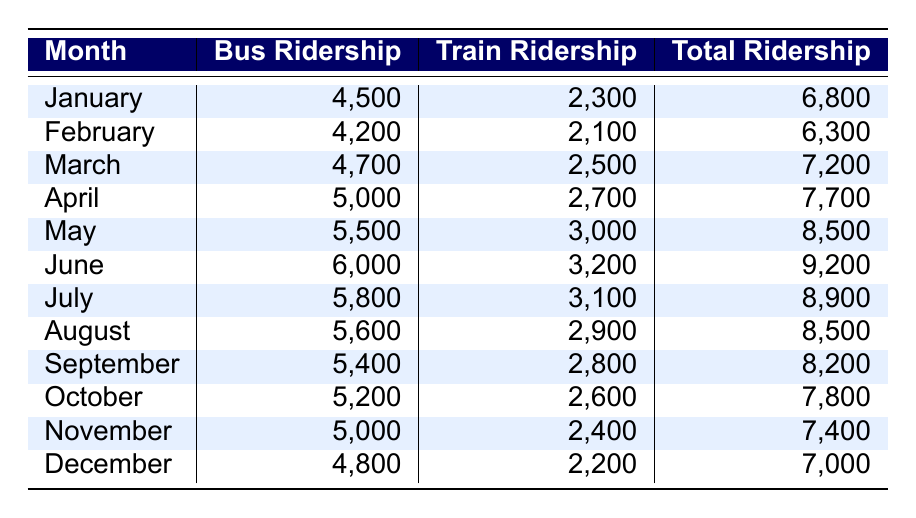What was the total ridership in June? The table shows that the total ridership for June is listed under the "Total Ridership" column. Referring to the row for June, the value is 9,200.
Answer: 9,200 Which month had the highest bus ridership? Looking at the "Bus Ridership" column, June has the highest value listed at 6,000, which is greater than all other monthly values.
Answer: June What is the average train ridership for the year? To find the average, sum all the train ridership values (2,300 + 2,100 + 2,500 + 2,700 + 3,000 + 3,200 + 3,100 + 2,900 + 2,800 + 2,600 + 2,400 + 2,200 = 35,900), then divide by the total number of months (12). This results in an average train ridership of 35,900 / 12 = 2,991.67, which rounds to approximately 2,992.
Answer: 2,992 Was the bus ridership higher in May or July? Comparing the values in the "Bus Ridership" column, May has 5,500 while July has 5,800. Since 5,800 is greater than 5,500, July had the higher bus ridership.
Answer: Yes, July had higher bus ridership than May What is the difference in total ridership between April and September? From the table, the total ridership for April is 7,700 and for September is 8,200. The difference is calculated as 8,200 - 7,700 = 500.
Answer: 500 In which month did the total ridership decrease compared to the previous month? Looking through the "Total Ridership" column, December has 7,000, which is lower than November's 7,400. This indicates a decrease from November to December.
Answer: December Which months had a total ridership above 8,000? To find this, we check the "Total Ridership" column. The months with total ridership above 8,000 are May (8,500), June (9,200), July (8,900), and August (8,500).
Answer: May, June, July, August Was the train ridership in March more than the bus ridership in the same month? In March, the train ridership is 2,500 and the bus ridership is 4,700. Since 4,700 is greater than 2,500, the train ridership was not more than the bus ridership.
Answer: No What was the total ridership for the months of February through April? Adding the total ridership for February (6,300), March (7,200), and April (7,700) gives 6,300 + 7,200 + 7,700 = 21,200.
Answer: 21,200 